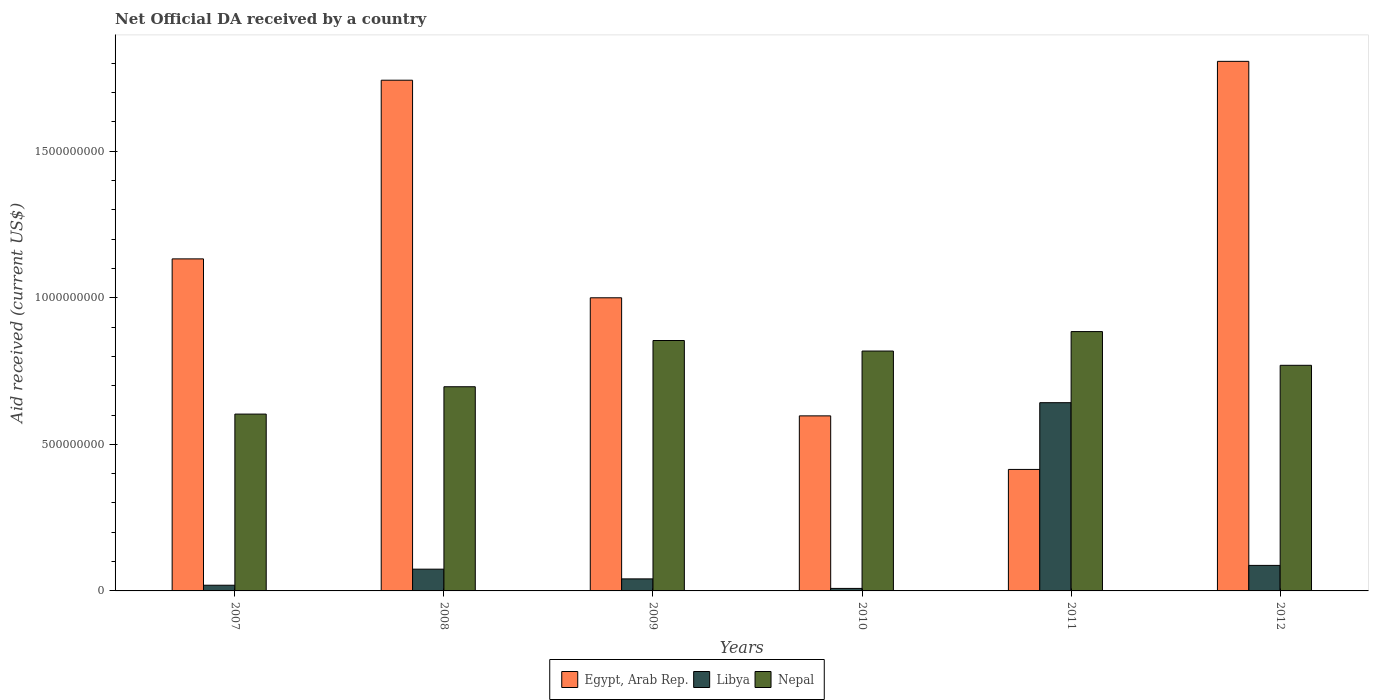Are the number of bars per tick equal to the number of legend labels?
Give a very brief answer. Yes. How many bars are there on the 5th tick from the right?
Give a very brief answer. 3. In how many cases, is the number of bars for a given year not equal to the number of legend labels?
Offer a terse response. 0. What is the net official development assistance aid received in Libya in 2008?
Offer a very short reply. 7.42e+07. Across all years, what is the maximum net official development assistance aid received in Libya?
Provide a short and direct response. 6.42e+08. Across all years, what is the minimum net official development assistance aid received in Egypt, Arab Rep.?
Offer a terse response. 4.14e+08. In which year was the net official development assistance aid received in Nepal minimum?
Offer a very short reply. 2007. What is the total net official development assistance aid received in Nepal in the graph?
Your answer should be very brief. 4.63e+09. What is the difference between the net official development assistance aid received in Nepal in 2009 and that in 2012?
Provide a short and direct response. 8.46e+07. What is the difference between the net official development assistance aid received in Egypt, Arab Rep. in 2008 and the net official development assistance aid received in Nepal in 2007?
Offer a very short reply. 1.14e+09. What is the average net official development assistance aid received in Nepal per year?
Offer a very short reply. 7.71e+08. In the year 2010, what is the difference between the net official development assistance aid received in Nepal and net official development assistance aid received in Egypt, Arab Rep.?
Provide a short and direct response. 2.21e+08. In how many years, is the net official development assistance aid received in Libya greater than 600000000 US$?
Ensure brevity in your answer.  1. What is the ratio of the net official development assistance aid received in Libya in 2007 to that in 2009?
Make the answer very short. 0.47. Is the net official development assistance aid received in Nepal in 2009 less than that in 2012?
Your answer should be very brief. No. What is the difference between the highest and the second highest net official development assistance aid received in Nepal?
Make the answer very short. 3.04e+07. What is the difference between the highest and the lowest net official development assistance aid received in Egypt, Arab Rep.?
Provide a succinct answer. 1.39e+09. In how many years, is the net official development assistance aid received in Nepal greater than the average net official development assistance aid received in Nepal taken over all years?
Make the answer very short. 3. What does the 2nd bar from the left in 2008 represents?
Offer a very short reply. Libya. What does the 3rd bar from the right in 2012 represents?
Provide a succinct answer. Egypt, Arab Rep. Are all the bars in the graph horizontal?
Give a very brief answer. No. What is the difference between two consecutive major ticks on the Y-axis?
Keep it short and to the point. 5.00e+08. Does the graph contain any zero values?
Your response must be concise. No. Does the graph contain grids?
Your response must be concise. No. Where does the legend appear in the graph?
Offer a terse response. Bottom center. How are the legend labels stacked?
Your response must be concise. Horizontal. What is the title of the graph?
Your response must be concise. Net Official DA received by a country. What is the label or title of the Y-axis?
Offer a terse response. Aid received (current US$). What is the Aid received (current US$) of Egypt, Arab Rep. in 2007?
Make the answer very short. 1.13e+09. What is the Aid received (current US$) in Libya in 2007?
Keep it short and to the point. 1.94e+07. What is the Aid received (current US$) of Nepal in 2007?
Make the answer very short. 6.03e+08. What is the Aid received (current US$) of Egypt, Arab Rep. in 2008?
Offer a very short reply. 1.74e+09. What is the Aid received (current US$) in Libya in 2008?
Your answer should be compact. 7.42e+07. What is the Aid received (current US$) of Nepal in 2008?
Give a very brief answer. 6.97e+08. What is the Aid received (current US$) in Egypt, Arab Rep. in 2009?
Ensure brevity in your answer.  1.00e+09. What is the Aid received (current US$) in Libya in 2009?
Your answer should be compact. 4.11e+07. What is the Aid received (current US$) of Nepal in 2009?
Give a very brief answer. 8.54e+08. What is the Aid received (current US$) in Egypt, Arab Rep. in 2010?
Offer a very short reply. 5.97e+08. What is the Aid received (current US$) in Libya in 2010?
Your answer should be very brief. 8.54e+06. What is the Aid received (current US$) in Nepal in 2010?
Keep it short and to the point. 8.18e+08. What is the Aid received (current US$) in Egypt, Arab Rep. in 2011?
Provide a succinct answer. 4.14e+08. What is the Aid received (current US$) of Libya in 2011?
Provide a short and direct response. 6.42e+08. What is the Aid received (current US$) of Nepal in 2011?
Give a very brief answer. 8.85e+08. What is the Aid received (current US$) in Egypt, Arab Rep. in 2012?
Make the answer very short. 1.81e+09. What is the Aid received (current US$) of Libya in 2012?
Offer a very short reply. 8.71e+07. What is the Aid received (current US$) in Nepal in 2012?
Make the answer very short. 7.70e+08. Across all years, what is the maximum Aid received (current US$) of Egypt, Arab Rep.?
Your answer should be very brief. 1.81e+09. Across all years, what is the maximum Aid received (current US$) in Libya?
Your answer should be very brief. 6.42e+08. Across all years, what is the maximum Aid received (current US$) in Nepal?
Give a very brief answer. 8.85e+08. Across all years, what is the minimum Aid received (current US$) in Egypt, Arab Rep.?
Keep it short and to the point. 4.14e+08. Across all years, what is the minimum Aid received (current US$) of Libya?
Your response must be concise. 8.54e+06. Across all years, what is the minimum Aid received (current US$) in Nepal?
Your response must be concise. 6.03e+08. What is the total Aid received (current US$) in Egypt, Arab Rep. in the graph?
Offer a very short reply. 6.69e+09. What is the total Aid received (current US$) in Libya in the graph?
Provide a succinct answer. 8.72e+08. What is the total Aid received (current US$) of Nepal in the graph?
Provide a succinct answer. 4.63e+09. What is the difference between the Aid received (current US$) in Egypt, Arab Rep. in 2007 and that in 2008?
Ensure brevity in your answer.  -6.10e+08. What is the difference between the Aid received (current US$) in Libya in 2007 and that in 2008?
Provide a short and direct response. -5.48e+07. What is the difference between the Aid received (current US$) in Nepal in 2007 and that in 2008?
Your answer should be compact. -9.33e+07. What is the difference between the Aid received (current US$) in Egypt, Arab Rep. in 2007 and that in 2009?
Offer a very short reply. 1.33e+08. What is the difference between the Aid received (current US$) of Libya in 2007 and that in 2009?
Ensure brevity in your answer.  -2.16e+07. What is the difference between the Aid received (current US$) of Nepal in 2007 and that in 2009?
Give a very brief answer. -2.51e+08. What is the difference between the Aid received (current US$) of Egypt, Arab Rep. in 2007 and that in 2010?
Offer a terse response. 5.36e+08. What is the difference between the Aid received (current US$) in Libya in 2007 and that in 2010?
Make the answer very short. 1.09e+07. What is the difference between the Aid received (current US$) of Nepal in 2007 and that in 2010?
Ensure brevity in your answer.  -2.15e+08. What is the difference between the Aid received (current US$) of Egypt, Arab Rep. in 2007 and that in 2011?
Ensure brevity in your answer.  7.18e+08. What is the difference between the Aid received (current US$) in Libya in 2007 and that in 2011?
Your response must be concise. -6.23e+08. What is the difference between the Aid received (current US$) of Nepal in 2007 and that in 2011?
Offer a very short reply. -2.81e+08. What is the difference between the Aid received (current US$) in Egypt, Arab Rep. in 2007 and that in 2012?
Give a very brief answer. -6.74e+08. What is the difference between the Aid received (current US$) of Libya in 2007 and that in 2012?
Provide a succinct answer. -6.77e+07. What is the difference between the Aid received (current US$) in Nepal in 2007 and that in 2012?
Keep it short and to the point. -1.66e+08. What is the difference between the Aid received (current US$) in Egypt, Arab Rep. in 2008 and that in 2009?
Your response must be concise. 7.42e+08. What is the difference between the Aid received (current US$) in Libya in 2008 and that in 2009?
Your answer should be compact. 3.31e+07. What is the difference between the Aid received (current US$) in Nepal in 2008 and that in 2009?
Provide a short and direct response. -1.58e+08. What is the difference between the Aid received (current US$) in Egypt, Arab Rep. in 2008 and that in 2010?
Offer a terse response. 1.15e+09. What is the difference between the Aid received (current US$) of Libya in 2008 and that in 2010?
Provide a short and direct response. 6.57e+07. What is the difference between the Aid received (current US$) in Nepal in 2008 and that in 2010?
Ensure brevity in your answer.  -1.22e+08. What is the difference between the Aid received (current US$) of Egypt, Arab Rep. in 2008 and that in 2011?
Make the answer very short. 1.33e+09. What is the difference between the Aid received (current US$) of Libya in 2008 and that in 2011?
Your response must be concise. -5.68e+08. What is the difference between the Aid received (current US$) of Nepal in 2008 and that in 2011?
Make the answer very short. -1.88e+08. What is the difference between the Aid received (current US$) of Egypt, Arab Rep. in 2008 and that in 2012?
Your answer should be compact. -6.43e+07. What is the difference between the Aid received (current US$) in Libya in 2008 and that in 2012?
Your response must be concise. -1.29e+07. What is the difference between the Aid received (current US$) in Nepal in 2008 and that in 2012?
Give a very brief answer. -7.32e+07. What is the difference between the Aid received (current US$) in Egypt, Arab Rep. in 2009 and that in 2010?
Your response must be concise. 4.03e+08. What is the difference between the Aid received (current US$) in Libya in 2009 and that in 2010?
Offer a terse response. 3.25e+07. What is the difference between the Aid received (current US$) of Nepal in 2009 and that in 2010?
Keep it short and to the point. 3.60e+07. What is the difference between the Aid received (current US$) of Egypt, Arab Rep. in 2009 and that in 2011?
Your answer should be very brief. 5.86e+08. What is the difference between the Aid received (current US$) of Libya in 2009 and that in 2011?
Your response must be concise. -6.01e+08. What is the difference between the Aid received (current US$) of Nepal in 2009 and that in 2011?
Your answer should be very brief. -3.04e+07. What is the difference between the Aid received (current US$) in Egypt, Arab Rep. in 2009 and that in 2012?
Provide a short and direct response. -8.07e+08. What is the difference between the Aid received (current US$) in Libya in 2009 and that in 2012?
Keep it short and to the point. -4.60e+07. What is the difference between the Aid received (current US$) in Nepal in 2009 and that in 2012?
Provide a succinct answer. 8.46e+07. What is the difference between the Aid received (current US$) in Egypt, Arab Rep. in 2010 and that in 2011?
Your answer should be compact. 1.83e+08. What is the difference between the Aid received (current US$) of Libya in 2010 and that in 2011?
Your answer should be compact. -6.34e+08. What is the difference between the Aid received (current US$) of Nepal in 2010 and that in 2011?
Provide a short and direct response. -6.64e+07. What is the difference between the Aid received (current US$) of Egypt, Arab Rep. in 2010 and that in 2012?
Your answer should be compact. -1.21e+09. What is the difference between the Aid received (current US$) in Libya in 2010 and that in 2012?
Your answer should be very brief. -7.86e+07. What is the difference between the Aid received (current US$) in Nepal in 2010 and that in 2012?
Your response must be concise. 4.86e+07. What is the difference between the Aid received (current US$) of Egypt, Arab Rep. in 2011 and that in 2012?
Give a very brief answer. -1.39e+09. What is the difference between the Aid received (current US$) of Libya in 2011 and that in 2012?
Your answer should be very brief. 5.55e+08. What is the difference between the Aid received (current US$) in Nepal in 2011 and that in 2012?
Your response must be concise. 1.15e+08. What is the difference between the Aid received (current US$) in Egypt, Arab Rep. in 2007 and the Aid received (current US$) in Libya in 2008?
Offer a very short reply. 1.06e+09. What is the difference between the Aid received (current US$) of Egypt, Arab Rep. in 2007 and the Aid received (current US$) of Nepal in 2008?
Your answer should be very brief. 4.36e+08. What is the difference between the Aid received (current US$) in Libya in 2007 and the Aid received (current US$) in Nepal in 2008?
Ensure brevity in your answer.  -6.77e+08. What is the difference between the Aid received (current US$) of Egypt, Arab Rep. in 2007 and the Aid received (current US$) of Libya in 2009?
Your answer should be compact. 1.09e+09. What is the difference between the Aid received (current US$) in Egypt, Arab Rep. in 2007 and the Aid received (current US$) in Nepal in 2009?
Provide a succinct answer. 2.78e+08. What is the difference between the Aid received (current US$) of Libya in 2007 and the Aid received (current US$) of Nepal in 2009?
Make the answer very short. -8.35e+08. What is the difference between the Aid received (current US$) of Egypt, Arab Rep. in 2007 and the Aid received (current US$) of Libya in 2010?
Give a very brief answer. 1.12e+09. What is the difference between the Aid received (current US$) in Egypt, Arab Rep. in 2007 and the Aid received (current US$) in Nepal in 2010?
Your answer should be compact. 3.14e+08. What is the difference between the Aid received (current US$) in Libya in 2007 and the Aid received (current US$) in Nepal in 2010?
Offer a very short reply. -7.99e+08. What is the difference between the Aid received (current US$) in Egypt, Arab Rep. in 2007 and the Aid received (current US$) in Libya in 2011?
Your response must be concise. 4.91e+08. What is the difference between the Aid received (current US$) of Egypt, Arab Rep. in 2007 and the Aid received (current US$) of Nepal in 2011?
Your answer should be compact. 2.48e+08. What is the difference between the Aid received (current US$) of Libya in 2007 and the Aid received (current US$) of Nepal in 2011?
Your answer should be compact. -8.65e+08. What is the difference between the Aid received (current US$) of Egypt, Arab Rep. in 2007 and the Aid received (current US$) of Libya in 2012?
Your response must be concise. 1.05e+09. What is the difference between the Aid received (current US$) in Egypt, Arab Rep. in 2007 and the Aid received (current US$) in Nepal in 2012?
Keep it short and to the point. 3.63e+08. What is the difference between the Aid received (current US$) in Libya in 2007 and the Aid received (current US$) in Nepal in 2012?
Provide a succinct answer. -7.50e+08. What is the difference between the Aid received (current US$) in Egypt, Arab Rep. in 2008 and the Aid received (current US$) in Libya in 2009?
Ensure brevity in your answer.  1.70e+09. What is the difference between the Aid received (current US$) of Egypt, Arab Rep. in 2008 and the Aid received (current US$) of Nepal in 2009?
Your response must be concise. 8.88e+08. What is the difference between the Aid received (current US$) of Libya in 2008 and the Aid received (current US$) of Nepal in 2009?
Ensure brevity in your answer.  -7.80e+08. What is the difference between the Aid received (current US$) of Egypt, Arab Rep. in 2008 and the Aid received (current US$) of Libya in 2010?
Your answer should be very brief. 1.73e+09. What is the difference between the Aid received (current US$) in Egypt, Arab Rep. in 2008 and the Aid received (current US$) in Nepal in 2010?
Your response must be concise. 9.24e+08. What is the difference between the Aid received (current US$) of Libya in 2008 and the Aid received (current US$) of Nepal in 2010?
Make the answer very short. -7.44e+08. What is the difference between the Aid received (current US$) of Egypt, Arab Rep. in 2008 and the Aid received (current US$) of Libya in 2011?
Provide a short and direct response. 1.10e+09. What is the difference between the Aid received (current US$) in Egypt, Arab Rep. in 2008 and the Aid received (current US$) in Nepal in 2011?
Provide a succinct answer. 8.58e+08. What is the difference between the Aid received (current US$) in Libya in 2008 and the Aid received (current US$) in Nepal in 2011?
Ensure brevity in your answer.  -8.11e+08. What is the difference between the Aid received (current US$) of Egypt, Arab Rep. in 2008 and the Aid received (current US$) of Libya in 2012?
Provide a succinct answer. 1.66e+09. What is the difference between the Aid received (current US$) of Egypt, Arab Rep. in 2008 and the Aid received (current US$) of Nepal in 2012?
Provide a succinct answer. 9.73e+08. What is the difference between the Aid received (current US$) in Libya in 2008 and the Aid received (current US$) in Nepal in 2012?
Ensure brevity in your answer.  -6.96e+08. What is the difference between the Aid received (current US$) of Egypt, Arab Rep. in 2009 and the Aid received (current US$) of Libya in 2010?
Make the answer very short. 9.91e+08. What is the difference between the Aid received (current US$) of Egypt, Arab Rep. in 2009 and the Aid received (current US$) of Nepal in 2010?
Ensure brevity in your answer.  1.82e+08. What is the difference between the Aid received (current US$) in Libya in 2009 and the Aid received (current US$) in Nepal in 2010?
Keep it short and to the point. -7.77e+08. What is the difference between the Aid received (current US$) in Egypt, Arab Rep. in 2009 and the Aid received (current US$) in Libya in 2011?
Give a very brief answer. 3.58e+08. What is the difference between the Aid received (current US$) in Egypt, Arab Rep. in 2009 and the Aid received (current US$) in Nepal in 2011?
Your answer should be very brief. 1.15e+08. What is the difference between the Aid received (current US$) in Libya in 2009 and the Aid received (current US$) in Nepal in 2011?
Your answer should be very brief. -8.44e+08. What is the difference between the Aid received (current US$) in Egypt, Arab Rep. in 2009 and the Aid received (current US$) in Libya in 2012?
Provide a short and direct response. 9.13e+08. What is the difference between the Aid received (current US$) of Egypt, Arab Rep. in 2009 and the Aid received (current US$) of Nepal in 2012?
Your answer should be compact. 2.30e+08. What is the difference between the Aid received (current US$) of Libya in 2009 and the Aid received (current US$) of Nepal in 2012?
Give a very brief answer. -7.29e+08. What is the difference between the Aid received (current US$) in Egypt, Arab Rep. in 2010 and the Aid received (current US$) in Libya in 2011?
Offer a very short reply. -4.50e+07. What is the difference between the Aid received (current US$) in Egypt, Arab Rep. in 2010 and the Aid received (current US$) in Nepal in 2011?
Your answer should be compact. -2.88e+08. What is the difference between the Aid received (current US$) of Libya in 2010 and the Aid received (current US$) of Nepal in 2011?
Your answer should be very brief. -8.76e+08. What is the difference between the Aid received (current US$) of Egypt, Arab Rep. in 2010 and the Aid received (current US$) of Libya in 2012?
Provide a succinct answer. 5.10e+08. What is the difference between the Aid received (current US$) of Egypt, Arab Rep. in 2010 and the Aid received (current US$) of Nepal in 2012?
Your response must be concise. -1.73e+08. What is the difference between the Aid received (current US$) of Libya in 2010 and the Aid received (current US$) of Nepal in 2012?
Ensure brevity in your answer.  -7.61e+08. What is the difference between the Aid received (current US$) in Egypt, Arab Rep. in 2011 and the Aid received (current US$) in Libya in 2012?
Offer a very short reply. 3.27e+08. What is the difference between the Aid received (current US$) of Egypt, Arab Rep. in 2011 and the Aid received (current US$) of Nepal in 2012?
Offer a very short reply. -3.55e+08. What is the difference between the Aid received (current US$) in Libya in 2011 and the Aid received (current US$) in Nepal in 2012?
Keep it short and to the point. -1.28e+08. What is the average Aid received (current US$) of Egypt, Arab Rep. per year?
Your answer should be very brief. 1.12e+09. What is the average Aid received (current US$) in Libya per year?
Give a very brief answer. 1.45e+08. What is the average Aid received (current US$) in Nepal per year?
Your answer should be compact. 7.71e+08. In the year 2007, what is the difference between the Aid received (current US$) in Egypt, Arab Rep. and Aid received (current US$) in Libya?
Offer a terse response. 1.11e+09. In the year 2007, what is the difference between the Aid received (current US$) in Egypt, Arab Rep. and Aid received (current US$) in Nepal?
Your response must be concise. 5.29e+08. In the year 2007, what is the difference between the Aid received (current US$) in Libya and Aid received (current US$) in Nepal?
Offer a terse response. -5.84e+08. In the year 2008, what is the difference between the Aid received (current US$) of Egypt, Arab Rep. and Aid received (current US$) of Libya?
Your answer should be very brief. 1.67e+09. In the year 2008, what is the difference between the Aid received (current US$) in Egypt, Arab Rep. and Aid received (current US$) in Nepal?
Give a very brief answer. 1.05e+09. In the year 2008, what is the difference between the Aid received (current US$) of Libya and Aid received (current US$) of Nepal?
Offer a very short reply. -6.22e+08. In the year 2009, what is the difference between the Aid received (current US$) in Egypt, Arab Rep. and Aid received (current US$) in Libya?
Your response must be concise. 9.59e+08. In the year 2009, what is the difference between the Aid received (current US$) of Egypt, Arab Rep. and Aid received (current US$) of Nepal?
Give a very brief answer. 1.46e+08. In the year 2009, what is the difference between the Aid received (current US$) in Libya and Aid received (current US$) in Nepal?
Offer a very short reply. -8.13e+08. In the year 2010, what is the difference between the Aid received (current US$) of Egypt, Arab Rep. and Aid received (current US$) of Libya?
Your answer should be compact. 5.89e+08. In the year 2010, what is the difference between the Aid received (current US$) of Egypt, Arab Rep. and Aid received (current US$) of Nepal?
Keep it short and to the point. -2.21e+08. In the year 2010, what is the difference between the Aid received (current US$) in Libya and Aid received (current US$) in Nepal?
Make the answer very short. -8.10e+08. In the year 2011, what is the difference between the Aid received (current US$) in Egypt, Arab Rep. and Aid received (current US$) in Libya?
Provide a short and direct response. -2.28e+08. In the year 2011, what is the difference between the Aid received (current US$) in Egypt, Arab Rep. and Aid received (current US$) in Nepal?
Offer a terse response. -4.70e+08. In the year 2011, what is the difference between the Aid received (current US$) in Libya and Aid received (current US$) in Nepal?
Your answer should be compact. -2.43e+08. In the year 2012, what is the difference between the Aid received (current US$) in Egypt, Arab Rep. and Aid received (current US$) in Libya?
Make the answer very short. 1.72e+09. In the year 2012, what is the difference between the Aid received (current US$) of Egypt, Arab Rep. and Aid received (current US$) of Nepal?
Provide a short and direct response. 1.04e+09. In the year 2012, what is the difference between the Aid received (current US$) in Libya and Aid received (current US$) in Nepal?
Your response must be concise. -6.83e+08. What is the ratio of the Aid received (current US$) in Egypt, Arab Rep. in 2007 to that in 2008?
Keep it short and to the point. 0.65. What is the ratio of the Aid received (current US$) in Libya in 2007 to that in 2008?
Your response must be concise. 0.26. What is the ratio of the Aid received (current US$) of Nepal in 2007 to that in 2008?
Your response must be concise. 0.87. What is the ratio of the Aid received (current US$) of Egypt, Arab Rep. in 2007 to that in 2009?
Your answer should be very brief. 1.13. What is the ratio of the Aid received (current US$) of Libya in 2007 to that in 2009?
Offer a very short reply. 0.47. What is the ratio of the Aid received (current US$) in Nepal in 2007 to that in 2009?
Your response must be concise. 0.71. What is the ratio of the Aid received (current US$) of Egypt, Arab Rep. in 2007 to that in 2010?
Ensure brevity in your answer.  1.9. What is the ratio of the Aid received (current US$) of Libya in 2007 to that in 2010?
Offer a terse response. 2.27. What is the ratio of the Aid received (current US$) in Nepal in 2007 to that in 2010?
Your answer should be very brief. 0.74. What is the ratio of the Aid received (current US$) in Egypt, Arab Rep. in 2007 to that in 2011?
Ensure brevity in your answer.  2.73. What is the ratio of the Aid received (current US$) in Libya in 2007 to that in 2011?
Keep it short and to the point. 0.03. What is the ratio of the Aid received (current US$) in Nepal in 2007 to that in 2011?
Ensure brevity in your answer.  0.68. What is the ratio of the Aid received (current US$) in Egypt, Arab Rep. in 2007 to that in 2012?
Offer a terse response. 0.63. What is the ratio of the Aid received (current US$) in Libya in 2007 to that in 2012?
Your answer should be very brief. 0.22. What is the ratio of the Aid received (current US$) in Nepal in 2007 to that in 2012?
Provide a short and direct response. 0.78. What is the ratio of the Aid received (current US$) in Egypt, Arab Rep. in 2008 to that in 2009?
Your answer should be very brief. 1.74. What is the ratio of the Aid received (current US$) in Libya in 2008 to that in 2009?
Provide a short and direct response. 1.81. What is the ratio of the Aid received (current US$) of Nepal in 2008 to that in 2009?
Keep it short and to the point. 0.82. What is the ratio of the Aid received (current US$) of Egypt, Arab Rep. in 2008 to that in 2010?
Offer a terse response. 2.92. What is the ratio of the Aid received (current US$) of Libya in 2008 to that in 2010?
Offer a very short reply. 8.69. What is the ratio of the Aid received (current US$) of Nepal in 2008 to that in 2010?
Offer a very short reply. 0.85. What is the ratio of the Aid received (current US$) in Egypt, Arab Rep. in 2008 to that in 2011?
Provide a succinct answer. 4.2. What is the ratio of the Aid received (current US$) of Libya in 2008 to that in 2011?
Your response must be concise. 0.12. What is the ratio of the Aid received (current US$) of Nepal in 2008 to that in 2011?
Provide a succinct answer. 0.79. What is the ratio of the Aid received (current US$) in Egypt, Arab Rep. in 2008 to that in 2012?
Provide a short and direct response. 0.96. What is the ratio of the Aid received (current US$) in Libya in 2008 to that in 2012?
Your answer should be very brief. 0.85. What is the ratio of the Aid received (current US$) of Nepal in 2008 to that in 2012?
Keep it short and to the point. 0.91. What is the ratio of the Aid received (current US$) of Egypt, Arab Rep. in 2009 to that in 2010?
Your response must be concise. 1.67. What is the ratio of the Aid received (current US$) in Libya in 2009 to that in 2010?
Provide a short and direct response. 4.81. What is the ratio of the Aid received (current US$) in Nepal in 2009 to that in 2010?
Provide a succinct answer. 1.04. What is the ratio of the Aid received (current US$) in Egypt, Arab Rep. in 2009 to that in 2011?
Give a very brief answer. 2.41. What is the ratio of the Aid received (current US$) in Libya in 2009 to that in 2011?
Give a very brief answer. 0.06. What is the ratio of the Aid received (current US$) of Nepal in 2009 to that in 2011?
Provide a short and direct response. 0.97. What is the ratio of the Aid received (current US$) of Egypt, Arab Rep. in 2009 to that in 2012?
Offer a very short reply. 0.55. What is the ratio of the Aid received (current US$) in Libya in 2009 to that in 2012?
Provide a short and direct response. 0.47. What is the ratio of the Aid received (current US$) in Nepal in 2009 to that in 2012?
Make the answer very short. 1.11. What is the ratio of the Aid received (current US$) of Egypt, Arab Rep. in 2010 to that in 2011?
Give a very brief answer. 1.44. What is the ratio of the Aid received (current US$) in Libya in 2010 to that in 2011?
Offer a terse response. 0.01. What is the ratio of the Aid received (current US$) of Nepal in 2010 to that in 2011?
Keep it short and to the point. 0.93. What is the ratio of the Aid received (current US$) of Egypt, Arab Rep. in 2010 to that in 2012?
Your response must be concise. 0.33. What is the ratio of the Aid received (current US$) of Libya in 2010 to that in 2012?
Your answer should be very brief. 0.1. What is the ratio of the Aid received (current US$) of Nepal in 2010 to that in 2012?
Provide a short and direct response. 1.06. What is the ratio of the Aid received (current US$) in Egypt, Arab Rep. in 2011 to that in 2012?
Your answer should be very brief. 0.23. What is the ratio of the Aid received (current US$) of Libya in 2011 to that in 2012?
Your answer should be compact. 7.37. What is the ratio of the Aid received (current US$) in Nepal in 2011 to that in 2012?
Provide a short and direct response. 1.15. What is the difference between the highest and the second highest Aid received (current US$) of Egypt, Arab Rep.?
Provide a succinct answer. 6.43e+07. What is the difference between the highest and the second highest Aid received (current US$) in Libya?
Ensure brevity in your answer.  5.55e+08. What is the difference between the highest and the second highest Aid received (current US$) of Nepal?
Make the answer very short. 3.04e+07. What is the difference between the highest and the lowest Aid received (current US$) in Egypt, Arab Rep.?
Your answer should be compact. 1.39e+09. What is the difference between the highest and the lowest Aid received (current US$) of Libya?
Your answer should be compact. 6.34e+08. What is the difference between the highest and the lowest Aid received (current US$) in Nepal?
Keep it short and to the point. 2.81e+08. 